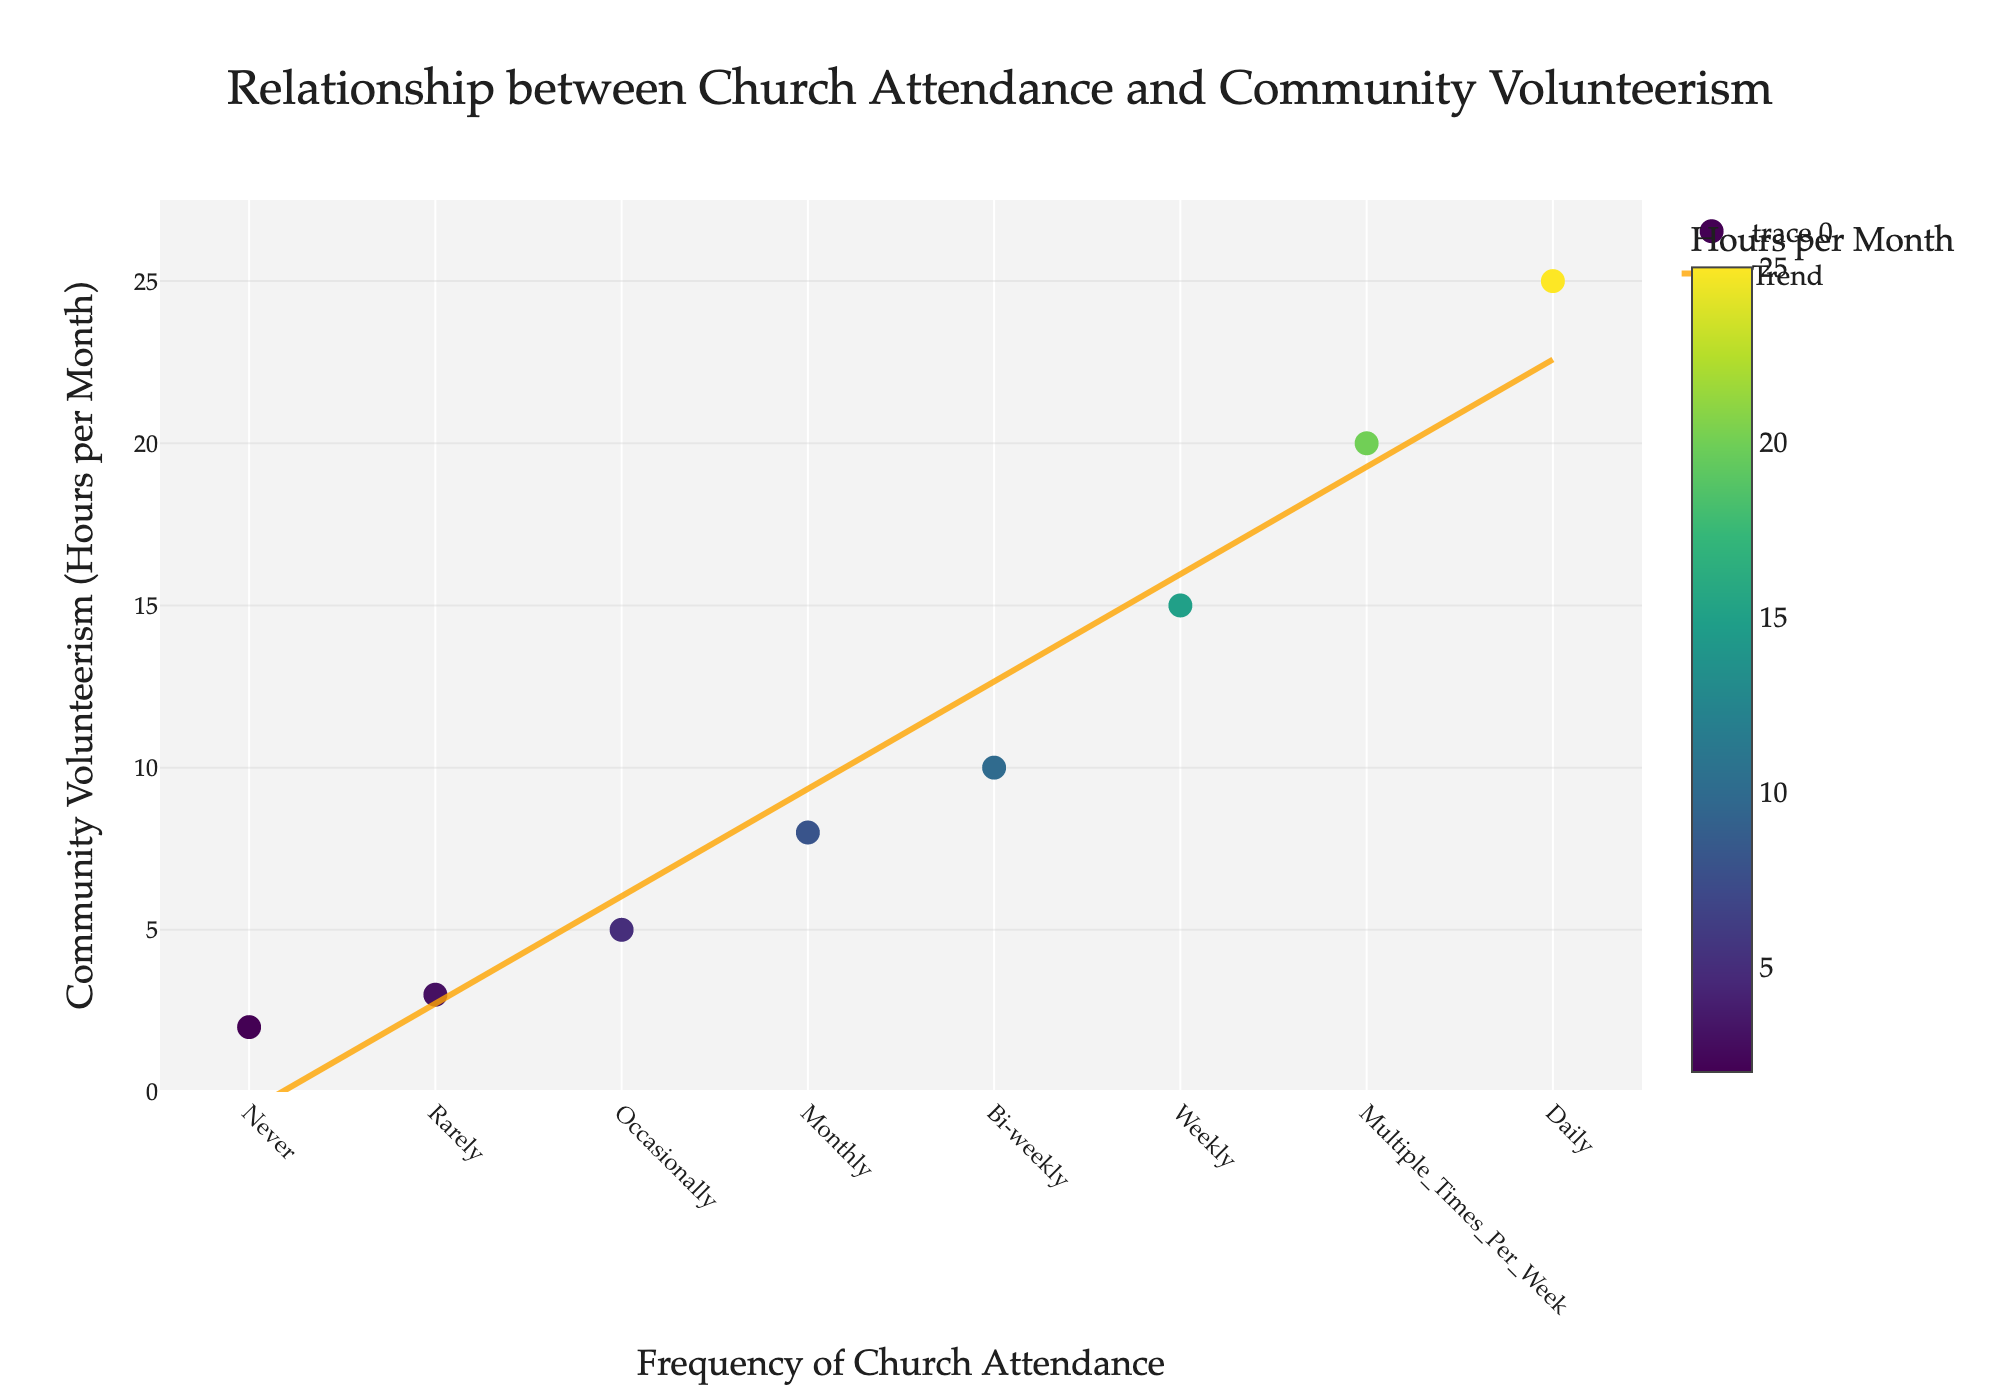What is the title of the plot? The title is located at the top of the plot. By reading the title, we can understand what relationship the figure intends to illustrate.
Answer: Relationship between Church Attendance and Community Volunteerism How many data points are there in the plot? By counting the markers (points) on the scatter plot, we can determine the number of data points.
Answer: 8 What does the color scale represent? The color scale displayed beside the plot, with the title "Hours per Month", indicates the range of colors corresponding to the community volunteerism hours.
Answer: Community volunteerism hours per month Which frequency of church attendance is associated with the highest community volunteerism hours? By looking at the highest point on the y-axis and corresponding it to the x-axis, we can identify the frequency of church attendance related to the highest volunteerism.
Answer: Daily What is the general trend shown by the trend line? The trend line helps us see the overall direction or pattern in the data points. We observe the slope of the line to determine this.
Answer: Increasing What is the community volunteerism hours per month for someone who attends church weekly? We locate the "Weekly" data point on the x-axis and match it to the y-value to find the corresponding volunteerism hours.
Answer: 15 On average, how many more volunteer hours per month do daily attendees contribute compared to those who attend church monthly? Calculate the difference between the volunteer hours for "Daily" and "Monthly" attendance.
Answer: 17 Are there any data points that significantly deviate from the trend line? By visually inspecting the distance of the points from the trend line, we identify any major outliers.
Answer: No significant deviations Does attending church bi-weekly result in more or less volunteer hours compared to monthly attendance? By comparing the y-values of "Bi-weekly" and "Monthly" data points, we determine the difference in volunteer hours.
Answer: More What change in volunteer hours do we observe as church attendance changes from "Occasionally" to "Weekly"? We find and subtract the y-values corresponding to "Occasionally" and "Weekly" to determine the change.
Answer: 10 Is the rate of increase in volunteerism hours constant or varying across different frequencies of church attendance? Observing the slope of different sections of the trend line helps us determine if the rate is constant or varying.
Answer: Almost constant but slightly varying 